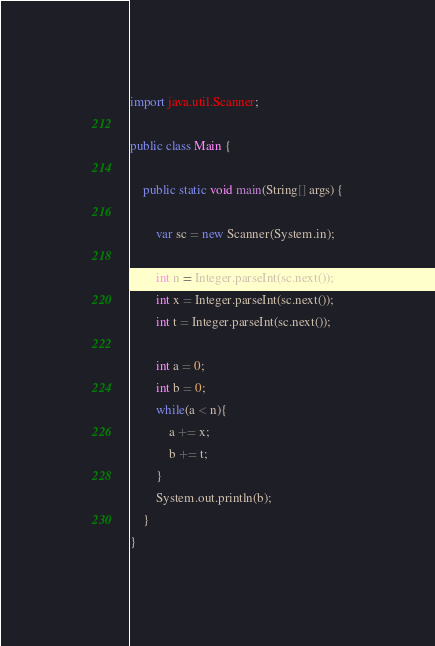<code> <loc_0><loc_0><loc_500><loc_500><_Java_>import java.util.Scanner;

public class Main {

    public static void main(String[] args) {
    
        var sc = new Scanner(System.in);
    
        int n = Integer.parseInt(sc.next());
        int x = Integer.parseInt(sc.next());
        int t = Integer.parseInt(sc.next());
        
        int a = 0;
        int b = 0;
        while(a < n){
            a += x;
            b += t;
        }
        System.out.println(b);
    }
}</code> 